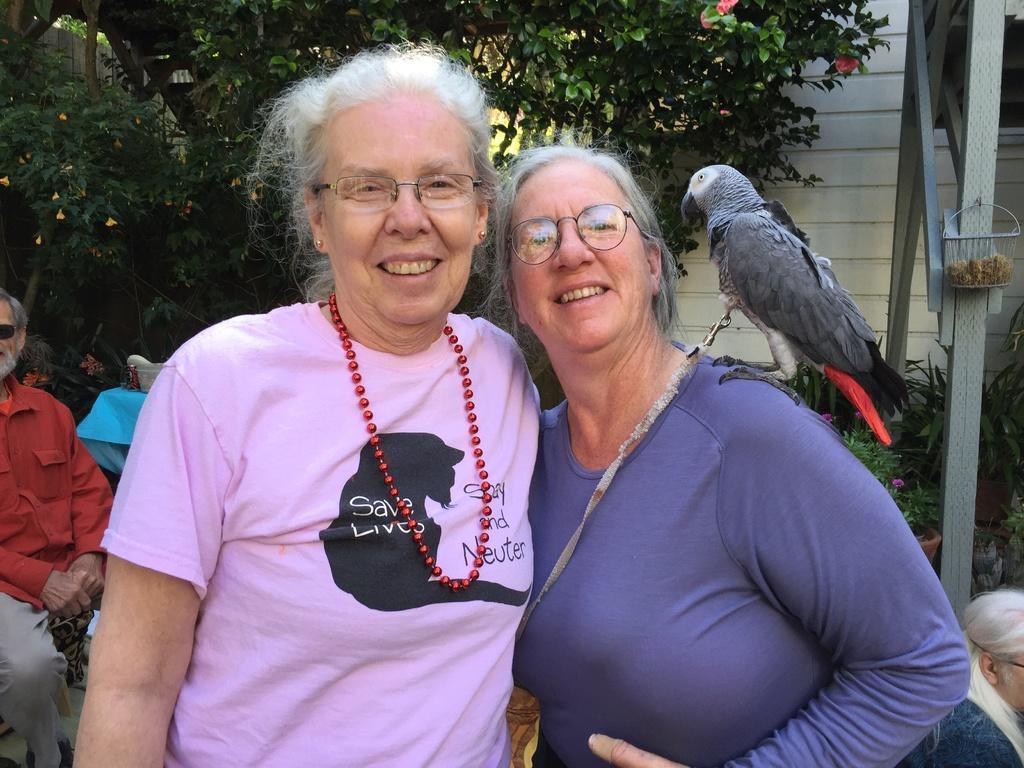In one or two sentences, can you explain what this image depicts? In the image we can see two women, standing, wearing clothes, spectacles and they are smiling. The left side woman is wearing neck chain and ear studs. Behind them there are other people, here we can see the bird, metal basket, plant pots and trees. 